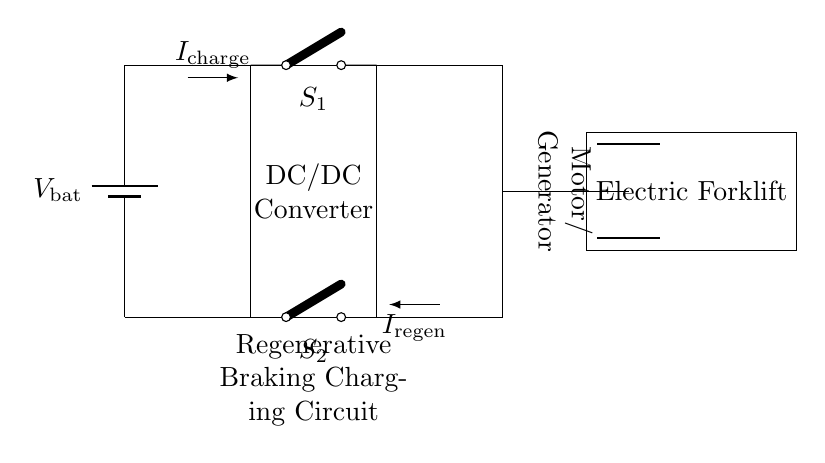What components are present in this circuit? The components visible in the circuit include a battery, a DC/DC converter, a motor/generator, and two switches labeled S1 and S2.
Answer: Battery, DC/DC converter, motor/generator, switches S1 and S2 What is the function of switch S1? Switch S1 is used to control the flow of current from the battery to the DC/DC converter when charging. When turned on, it allows current to flow to charge the battery.
Answer: Charging control What is the direction of the current during regenerative braking? During regenerative braking, current flows from the motor/generator back into the battery via the DC/DC converter. This is indicated by the current direction arrow labeled I_regen.
Answer: From motor/generator to battery How many main operating states can this circuit have? The circuit can operate in two main states: charging mode, where the battery is charged from the DC/DC converter, and regenerative mode, where the motor/generator acts to recharge the battery.
Answer: Two What is the role of the DC/DC converter in this circuit? The DC/DC converter serves to adapt the voltage level necessary for proper charging of the battery, managing the condition of current flow based on the operation mode (charging or regenerative).
Answer: Voltage adaptation What is the current labeled I_charge represent? The current labeled I_charge represents the charging current flowing from the battery through the DC/DC converter to charge the battery.
Answer: Charging current In which part of the diagram is the electric forklift located? The electric forklift is located on the right side of the circuit diagram, clearly labeled, and connected to the motor/generator.
Answer: Right side 